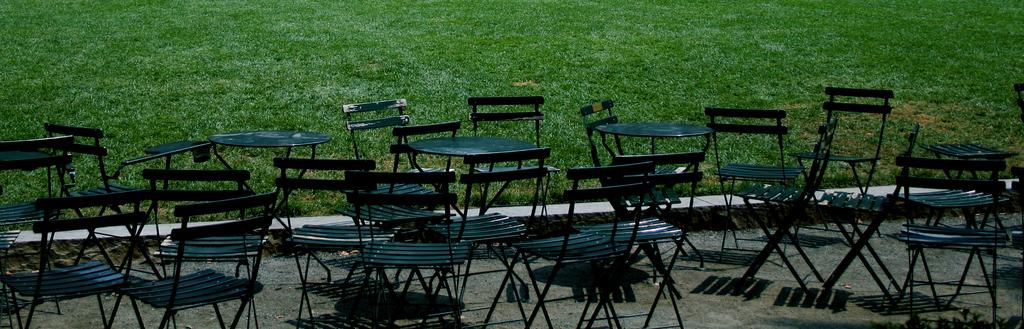What type of furniture can be seen in the foreground of the picture? There are chairs and tables in the foreground of the picture. What type of surface is visible at the top of the image? There is grass at the top of the image. What type of surface is visible at the bottom of the image? There is soil at the bottom of the image. What is the texture of the ice in the image? There is no ice present in the image, so it is not possible to determine its texture. 